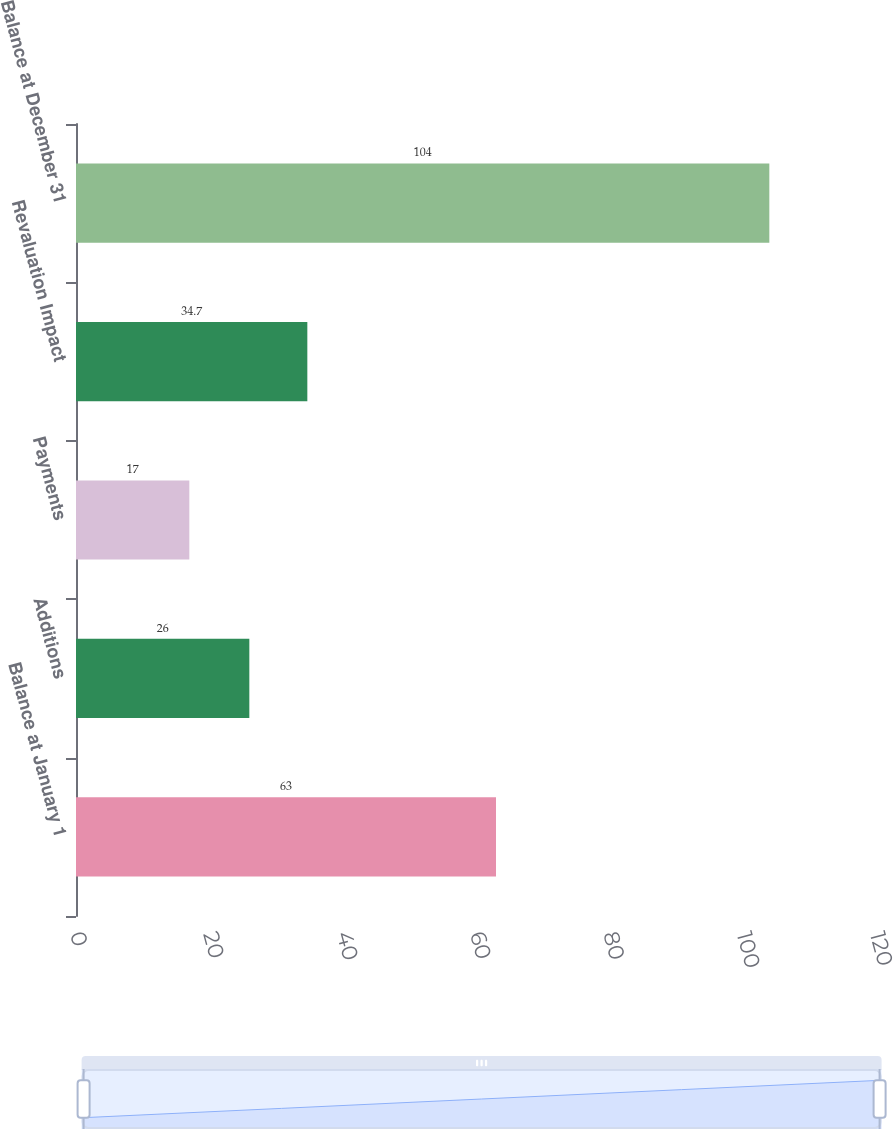Convert chart. <chart><loc_0><loc_0><loc_500><loc_500><bar_chart><fcel>Balance at January 1<fcel>Additions<fcel>Payments<fcel>Revaluation Impact<fcel>Balance at December 31<nl><fcel>63<fcel>26<fcel>17<fcel>34.7<fcel>104<nl></chart> 